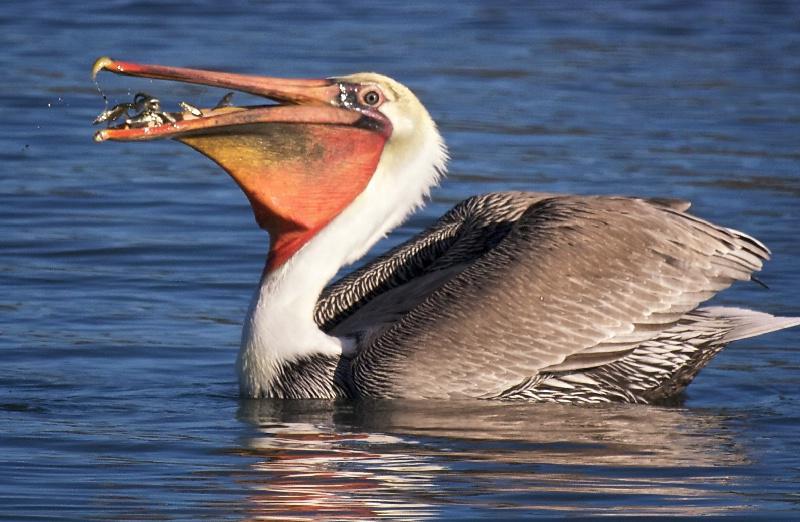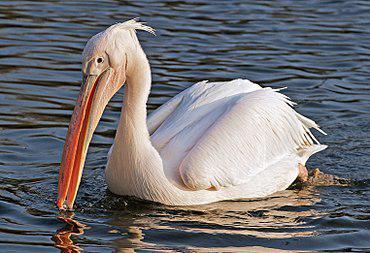The first image is the image on the left, the second image is the image on the right. Considering the images on both sides, is "At least one bird is standing, not swimming." valid? Answer yes or no. No. 